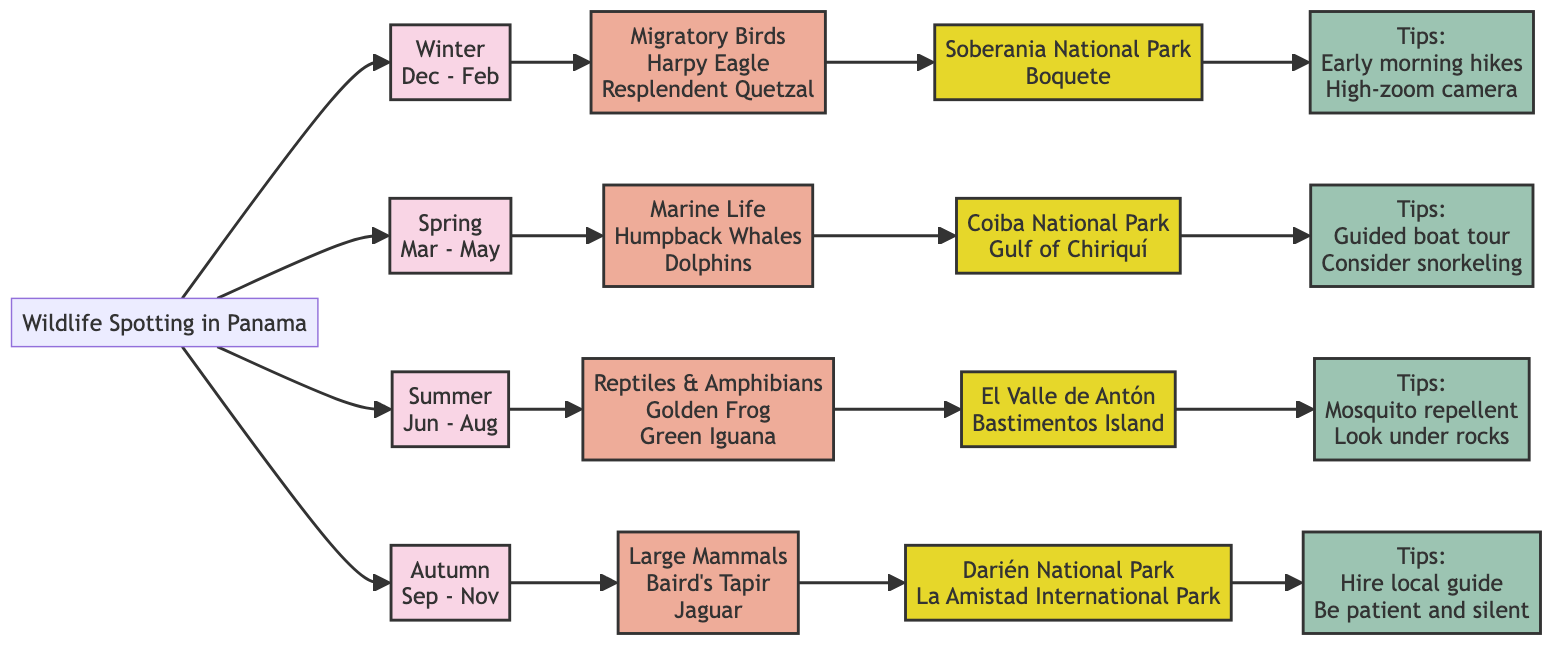What wildlife is spotted in Winter? The diagram indicates that during Winter, the wildlife type is "Migratory Birds," featuring key species like the "Harpy Eagle" and "Resplendent Quetzal."
Answer: Migratory Birds How many seasons are represented in the diagram? By reviewing the flowchart, we identify four seasons: Winter, Spring, Summer, and Autumn, which are indicated as distinct branches.
Answer: 4 Which season is associated with large mammals? The flowchart shows that large mammals, including "Baird's Tapir" and "Jaguar," are spotted during Autumn.
Answer: Autumn What are two locations for spotting migratory birds? The diagram lists "Soberania National Park" and "Boquete" as specific locations where migratory birds can be observed in Winter.
Answer: Soberania National Park, Boquete When is the best time to see Humpback Whales? According to the information, Humpback Whales are primarily seen from March to May, which corresponds with the Spring season.
Answer: March to May What is one tip for observing amphibians? The chart suggests wearing mosquito repellent and looking under rocks and fallen leaves to enhance the chances of seeing hidden amphibians during Summer.
Answer: Look under rocks Which wildlife type is linked to the Spring season? The diagram indicates that the wildlife type associated with Spring is "Marine Life," which includes "Humpback Whales" and "Dolphins."
Answer: Marine Life What is advised for better sighting chances in Autumn? The flowchart advises hiring an experienced local guide to improve the chances of spotting the large mammals present in Autumn.
Answer: Hire an experienced local guide What is the wildlife sighting in Summer? The summer season is associated with reptiles and amphibians, specifically the "Golden Frog" and "Green Iguana," according to the flowchart.
Answer: Reptiles and Amphibians 